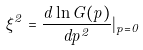<formula> <loc_0><loc_0><loc_500><loc_500>\xi ^ { 2 } = \frac { d \ln G ( p ) } { d p ^ { 2 } } | _ { p = 0 }</formula> 